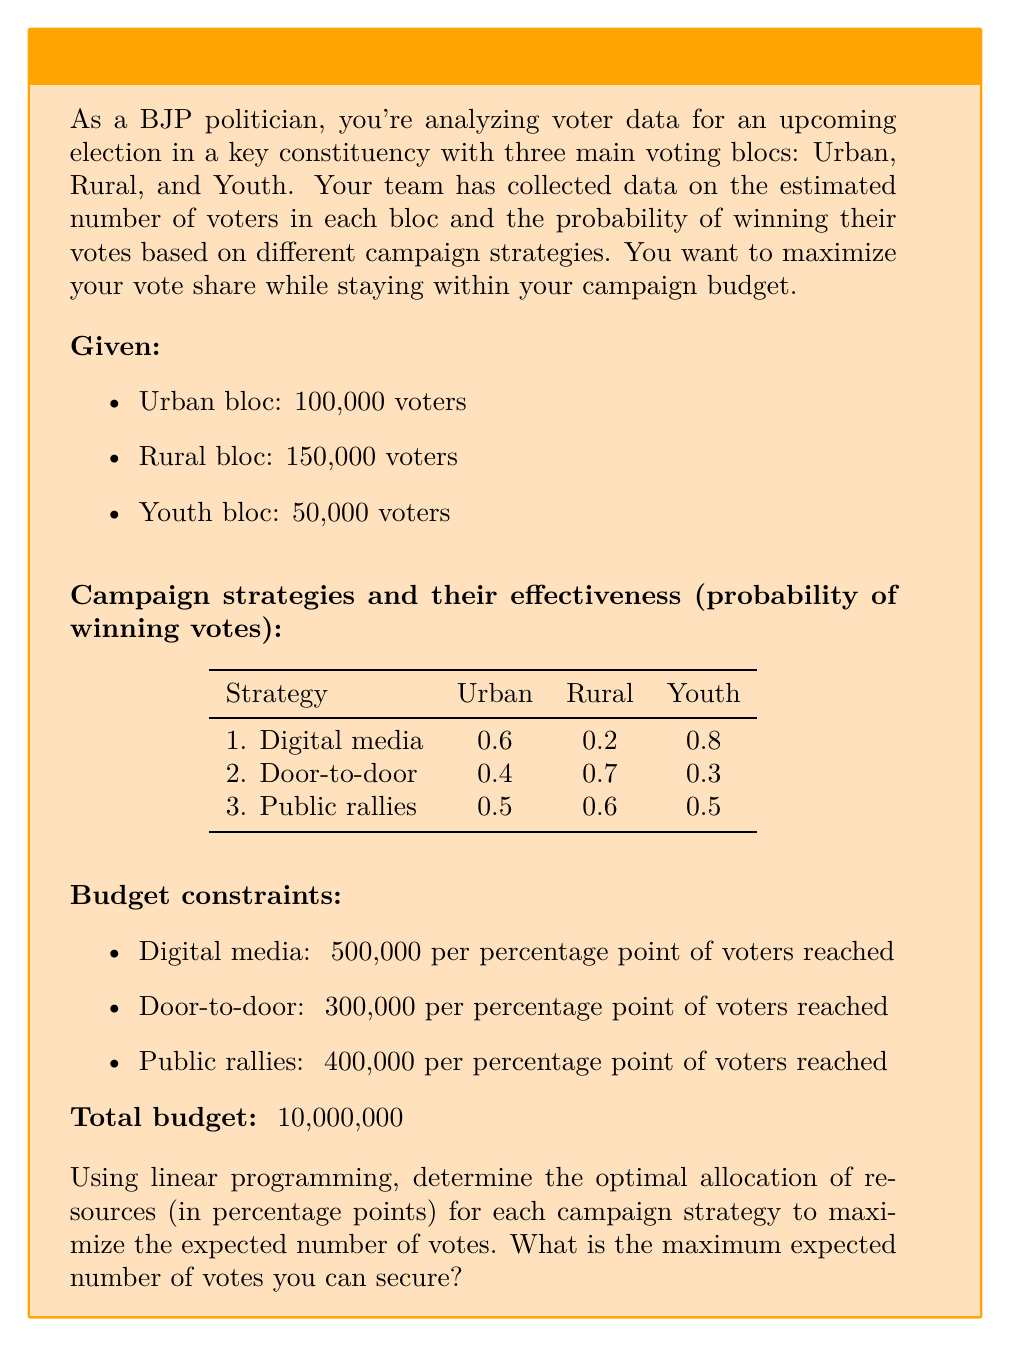What is the answer to this math problem? Let's approach this step-by-step using linear programming:

1. Define variables:
   Let $x_1$, $x_2$, and $x_3$ be the percentage points allocated to digital media, door-to-door, and public rallies respectively.

2. Objective function:
   Maximize expected votes: 
   $$Z = (100000 \cdot 0.6 + 150000 \cdot 0.2 + 50000 \cdot 0.8)x_1 + (100000 \cdot 0.4 + 150000 \cdot 0.7 + 50000 \cdot 0.3)x_2 + (100000 \cdot 0.5 + 150000 \cdot 0.6 + 50000 \cdot 0.5)x_3$$
   Simplified: $$Z = 110000x_1 + 145000x_2 + 140000x_3$$

3. Constraints:
   Budget: $500000x_1 + 300000x_2 + 400000x_3 \leq 10000000$
   Non-negativity: $x_1, x_2, x_3 \geq 0$
   Percentage limits: $x_1, x_2, x_3 \leq 100$

4. Solve using the simplex method or linear programming software:

   The optimal solution is:
   $x_1 = 10$, $x_2 = 20$, $x_3 = 5$

5. Calculate the maximum expected votes:
   $$Z = 110000 \cdot 10 + 145000 \cdot 20 + 140000 \cdot 5 = 4,800,000$$

Therefore, the optimal allocation is 10% to digital media, 20% to door-to-door campaigning, and 5% to public rallies. This strategy is expected to secure 4,800,000 votes.
Answer: 4,800,000 votes 